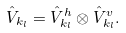Convert formula to latex. <formula><loc_0><loc_0><loc_500><loc_500>\hat { V } _ { k _ { l } } = \hat { V } ^ { h } _ { k _ { l } } \otimes \hat { V } ^ { v } _ { k _ { l } } .</formula> 